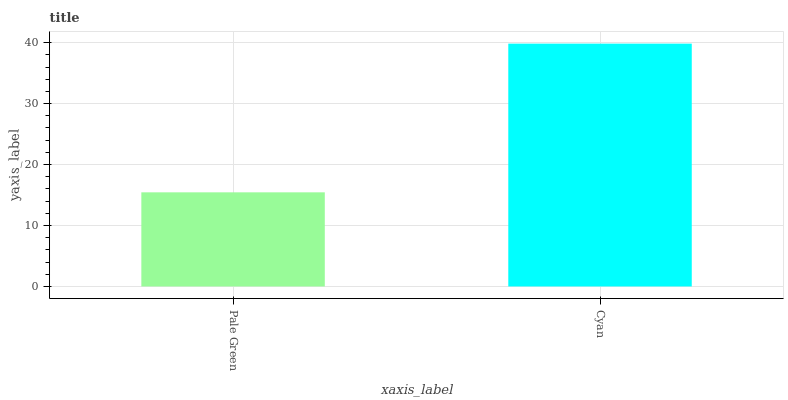Is Cyan the minimum?
Answer yes or no. No. Is Cyan greater than Pale Green?
Answer yes or no. Yes. Is Pale Green less than Cyan?
Answer yes or no. Yes. Is Pale Green greater than Cyan?
Answer yes or no. No. Is Cyan less than Pale Green?
Answer yes or no. No. Is Cyan the high median?
Answer yes or no. Yes. Is Pale Green the low median?
Answer yes or no. Yes. Is Pale Green the high median?
Answer yes or no. No. Is Cyan the low median?
Answer yes or no. No. 